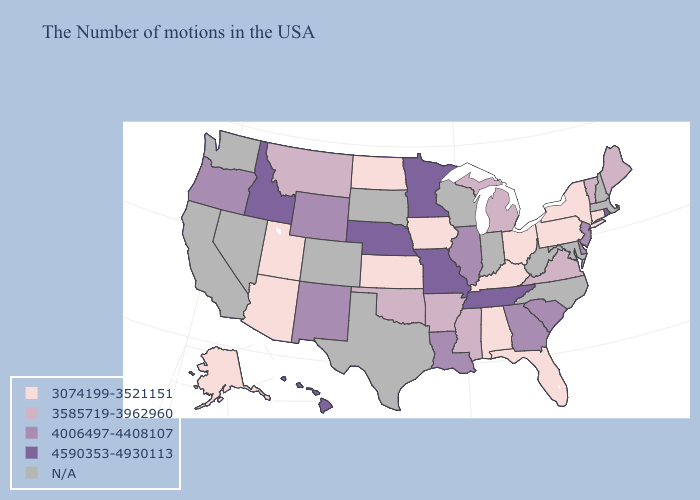Does Tennessee have the highest value in the USA?
Concise answer only. Yes. Does Pennsylvania have the highest value in the Northeast?
Give a very brief answer. No. Among the states that border New Jersey , does Delaware have the highest value?
Quick response, please. Yes. Among the states that border Tennessee , does Missouri have the highest value?
Be succinct. Yes. What is the value of Michigan?
Be succinct. 3585719-3962960. Is the legend a continuous bar?
Concise answer only. No. What is the highest value in states that border Michigan?
Give a very brief answer. 3074199-3521151. What is the value of Rhode Island?
Write a very short answer. 4590353-4930113. Does the first symbol in the legend represent the smallest category?
Quick response, please. Yes. What is the value of Pennsylvania?
Quick response, please. 3074199-3521151. Does Florida have the highest value in the USA?
Answer briefly. No. What is the lowest value in states that border Nebraska?
Write a very short answer. 3074199-3521151. How many symbols are there in the legend?
Answer briefly. 5. Does Virginia have the lowest value in the South?
Keep it brief. No. 